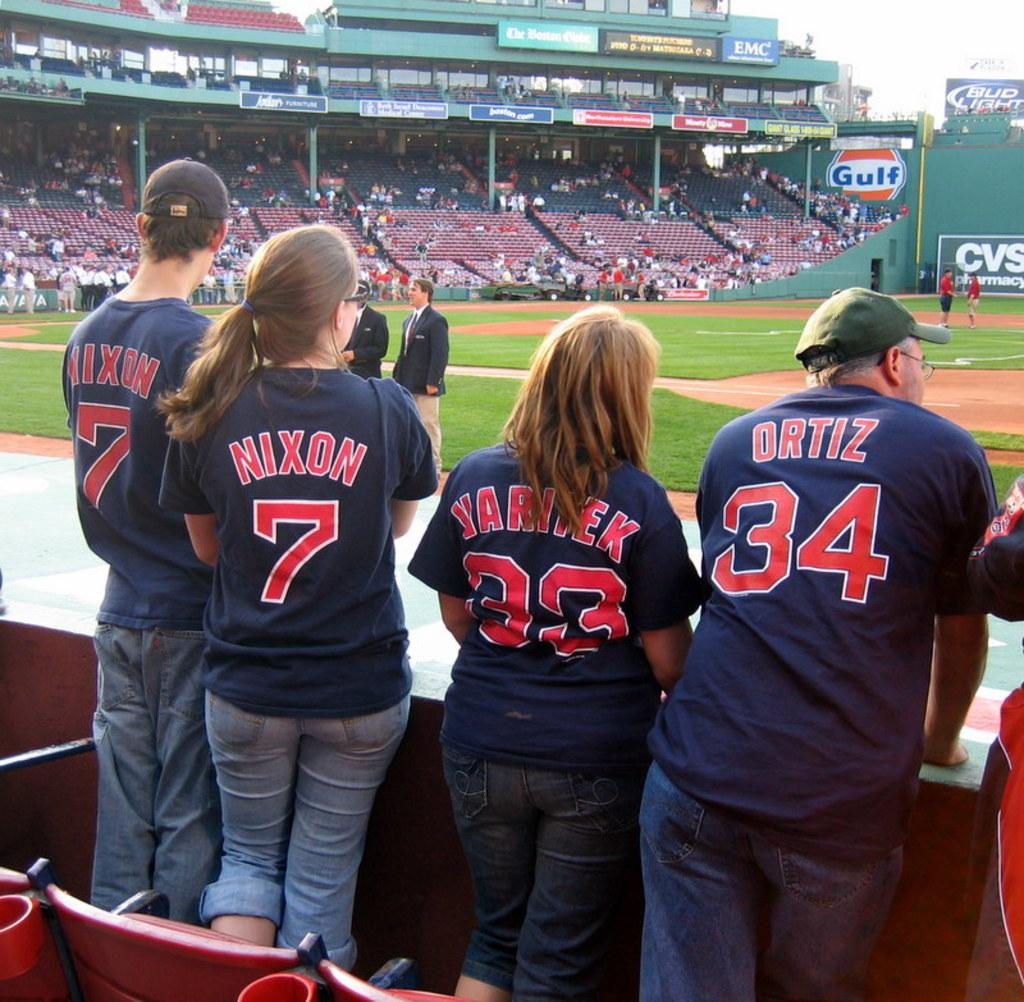<image>
Offer a succinct explanation of the picture presented. Nixon and Ortiz are two of the names seen on the back of their shirts. 